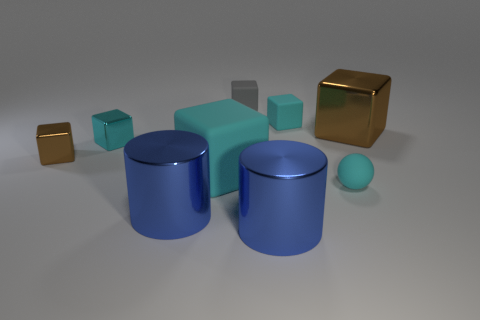Add 1 small cyan rubber cubes. How many objects exist? 10 Subtract all small cyan rubber cubes. How many cubes are left? 5 Subtract all cyan blocks. How many blocks are left? 3 Subtract 2 cylinders. How many cylinders are left? 0 Add 2 cubes. How many cubes exist? 8 Subtract 0 green balls. How many objects are left? 9 Subtract all cylinders. How many objects are left? 7 Subtract all blue cubes. Subtract all blue balls. How many cubes are left? 6 Subtract all gray cylinders. How many red spheres are left? 0 Subtract all metallic blocks. Subtract all metal objects. How many objects are left? 1 